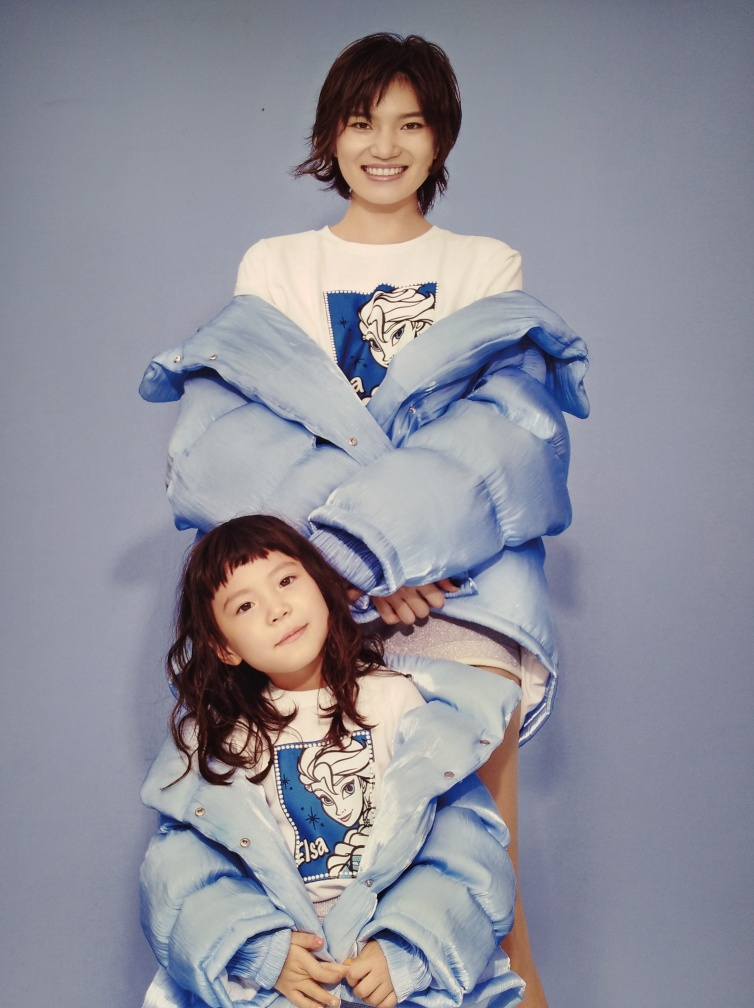What can be said about the clarity of this image?
A. Overall, this image is hazy.
B. Overall, this image is quite clear.
C. Overall, this image is blurry.
Answer with the option's letter from the given choices directly.
 B. 